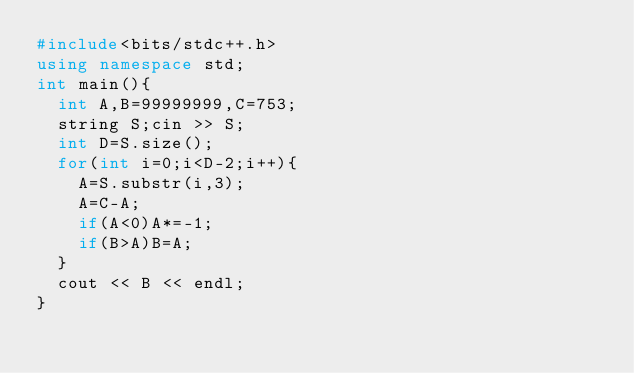<code> <loc_0><loc_0><loc_500><loc_500><_C++_>#include<bits/stdc++.h>
using namespace std;
int main(){
  int A,B=99999999,C=753;
  string S;cin >> S;
  int D=S.size();
  for(int i=0;i<D-2;i++){
    A=S.substr(i,3);
    A=C-A;
    if(A<0)A*=-1;
    if(B>A)B=A;
  }
  cout << B << endl;
}
</code> 